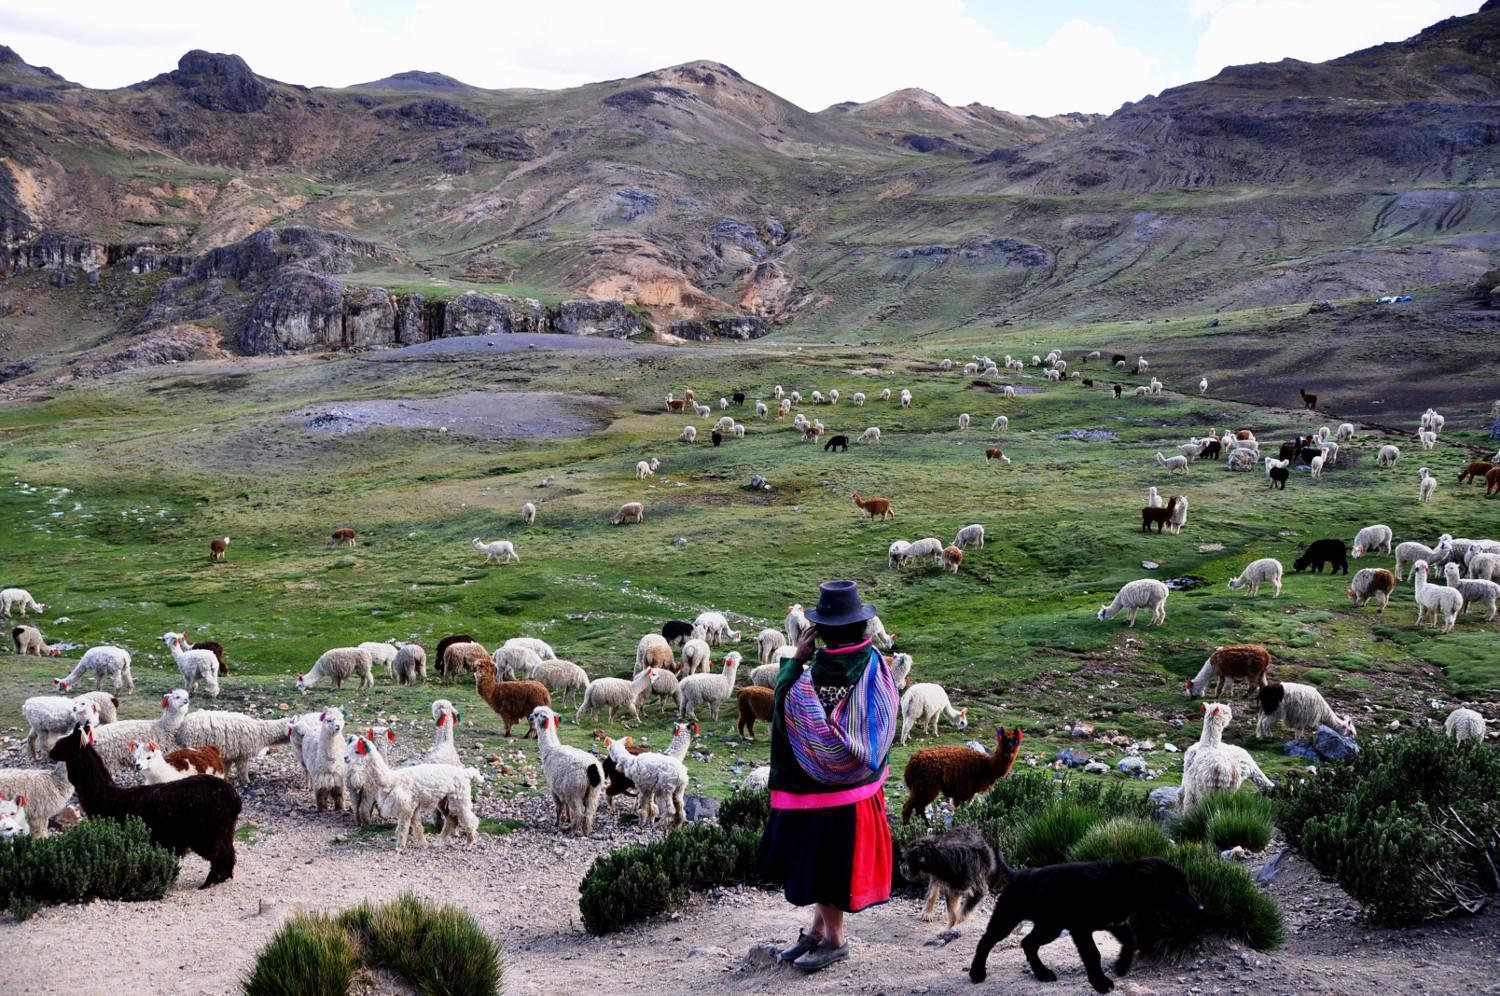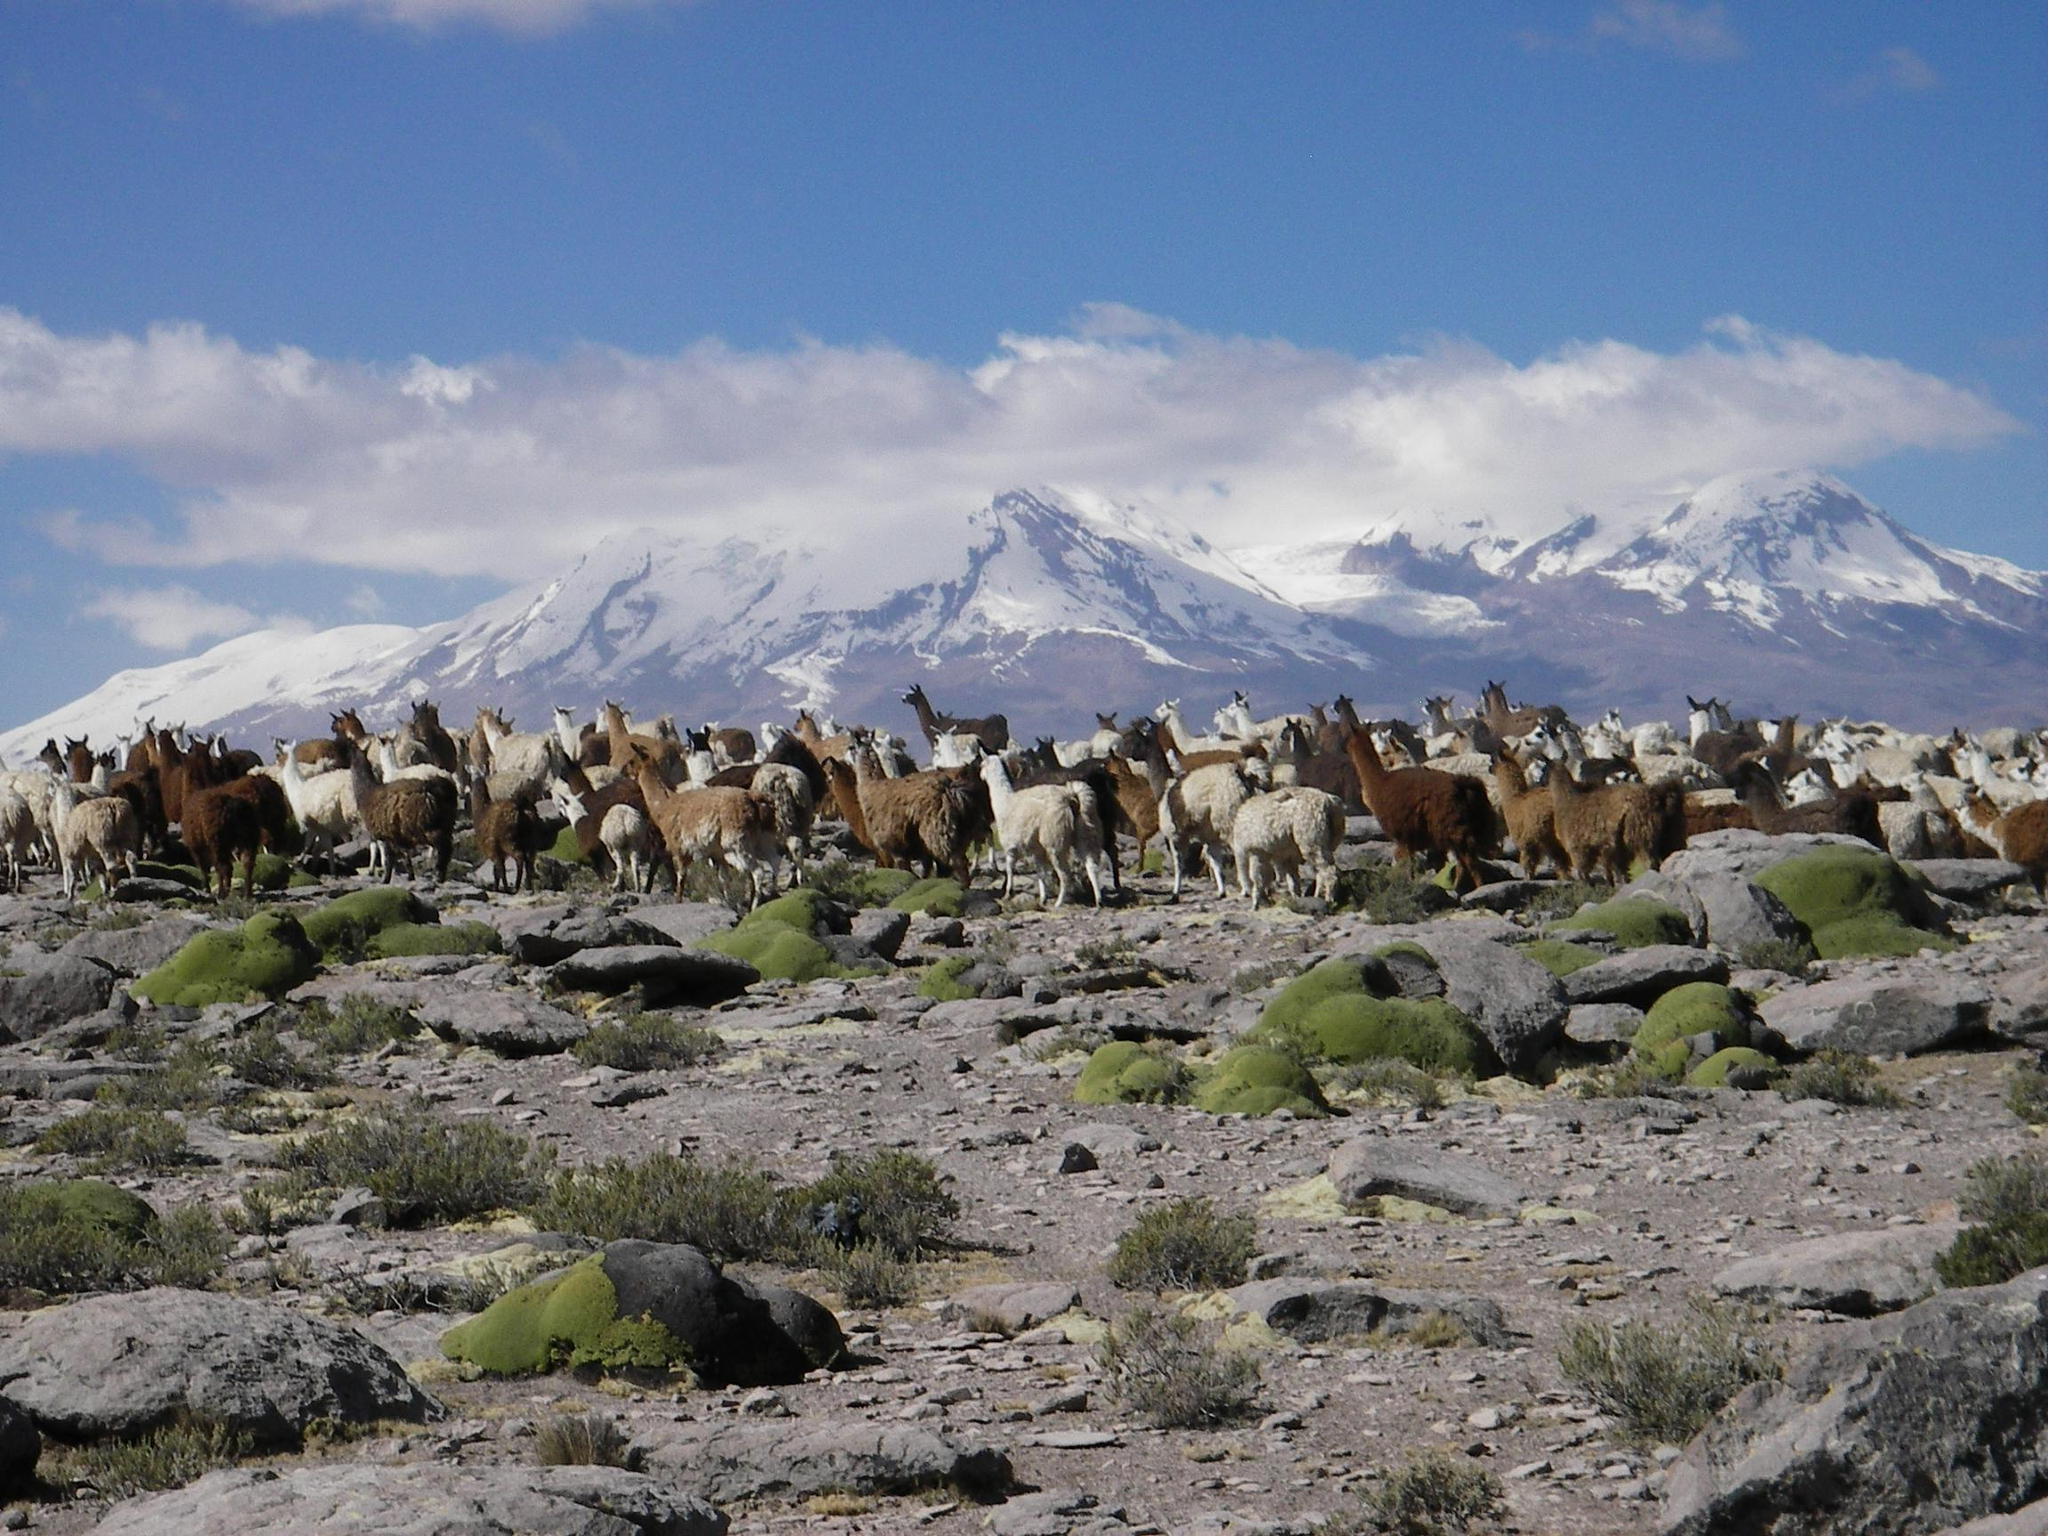The first image is the image on the left, the second image is the image on the right. Considering the images on both sides, is "In the right image, fewer than ten llamas wander through grass scrubs, and a snow covered mountain is in the background." valid? Answer yes or no. No. The first image is the image on the left, the second image is the image on the right. Evaluate the accuracy of this statement regarding the images: "The right image shows a line of rightward facing llamas standing on ground with sparse foliage and mountain peaks in the background.". Is it true? Answer yes or no. No. 